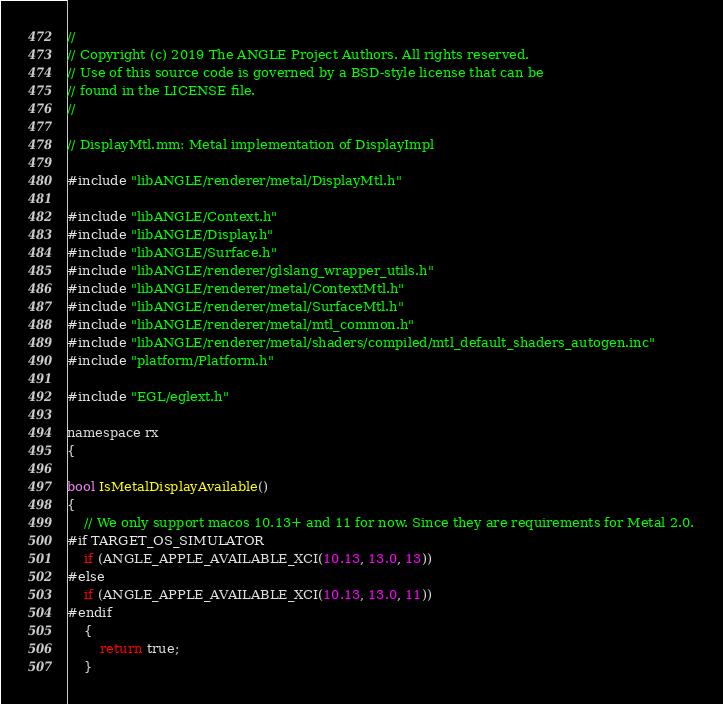<code> <loc_0><loc_0><loc_500><loc_500><_ObjectiveC_>//
// Copyright (c) 2019 The ANGLE Project Authors. All rights reserved.
// Use of this source code is governed by a BSD-style license that can be
// found in the LICENSE file.
//

// DisplayMtl.mm: Metal implementation of DisplayImpl

#include "libANGLE/renderer/metal/DisplayMtl.h"

#include "libANGLE/Context.h"
#include "libANGLE/Display.h"
#include "libANGLE/Surface.h"
#include "libANGLE/renderer/glslang_wrapper_utils.h"
#include "libANGLE/renderer/metal/ContextMtl.h"
#include "libANGLE/renderer/metal/SurfaceMtl.h"
#include "libANGLE/renderer/metal/mtl_common.h"
#include "libANGLE/renderer/metal/shaders/compiled/mtl_default_shaders_autogen.inc"
#include "platform/Platform.h"

#include "EGL/eglext.h"

namespace rx
{

bool IsMetalDisplayAvailable()
{
    // We only support macos 10.13+ and 11 for now. Since they are requirements for Metal 2.0.
#if TARGET_OS_SIMULATOR
    if (ANGLE_APPLE_AVAILABLE_XCI(10.13, 13.0, 13))
#else
    if (ANGLE_APPLE_AVAILABLE_XCI(10.13, 13.0, 11))
#endif
    {
        return true;
    }</code> 